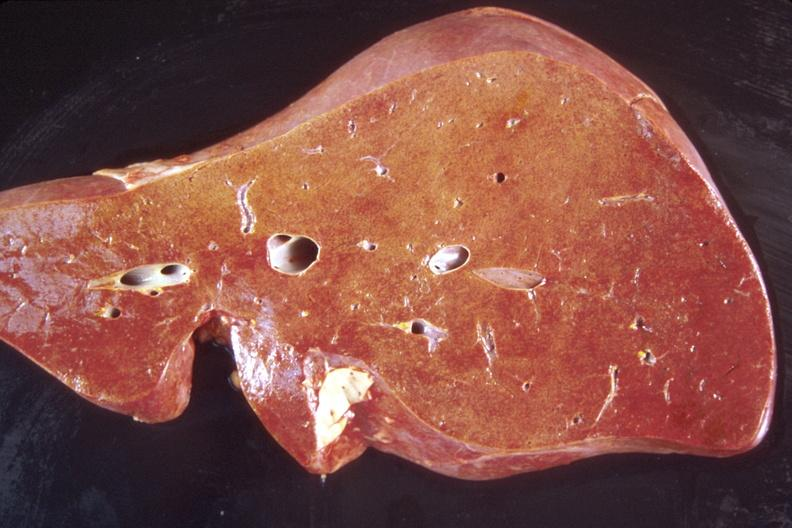s hepatobiliary present?
Answer the question using a single word or phrase. Yes 